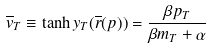Convert formula to latex. <formula><loc_0><loc_0><loc_500><loc_500>\overline { v } _ { T } \equiv \tanh y _ { T } ( \overline { r } ( p ) ) = \frac { \beta p _ { T } } { \beta m _ { T } + \alpha }</formula> 